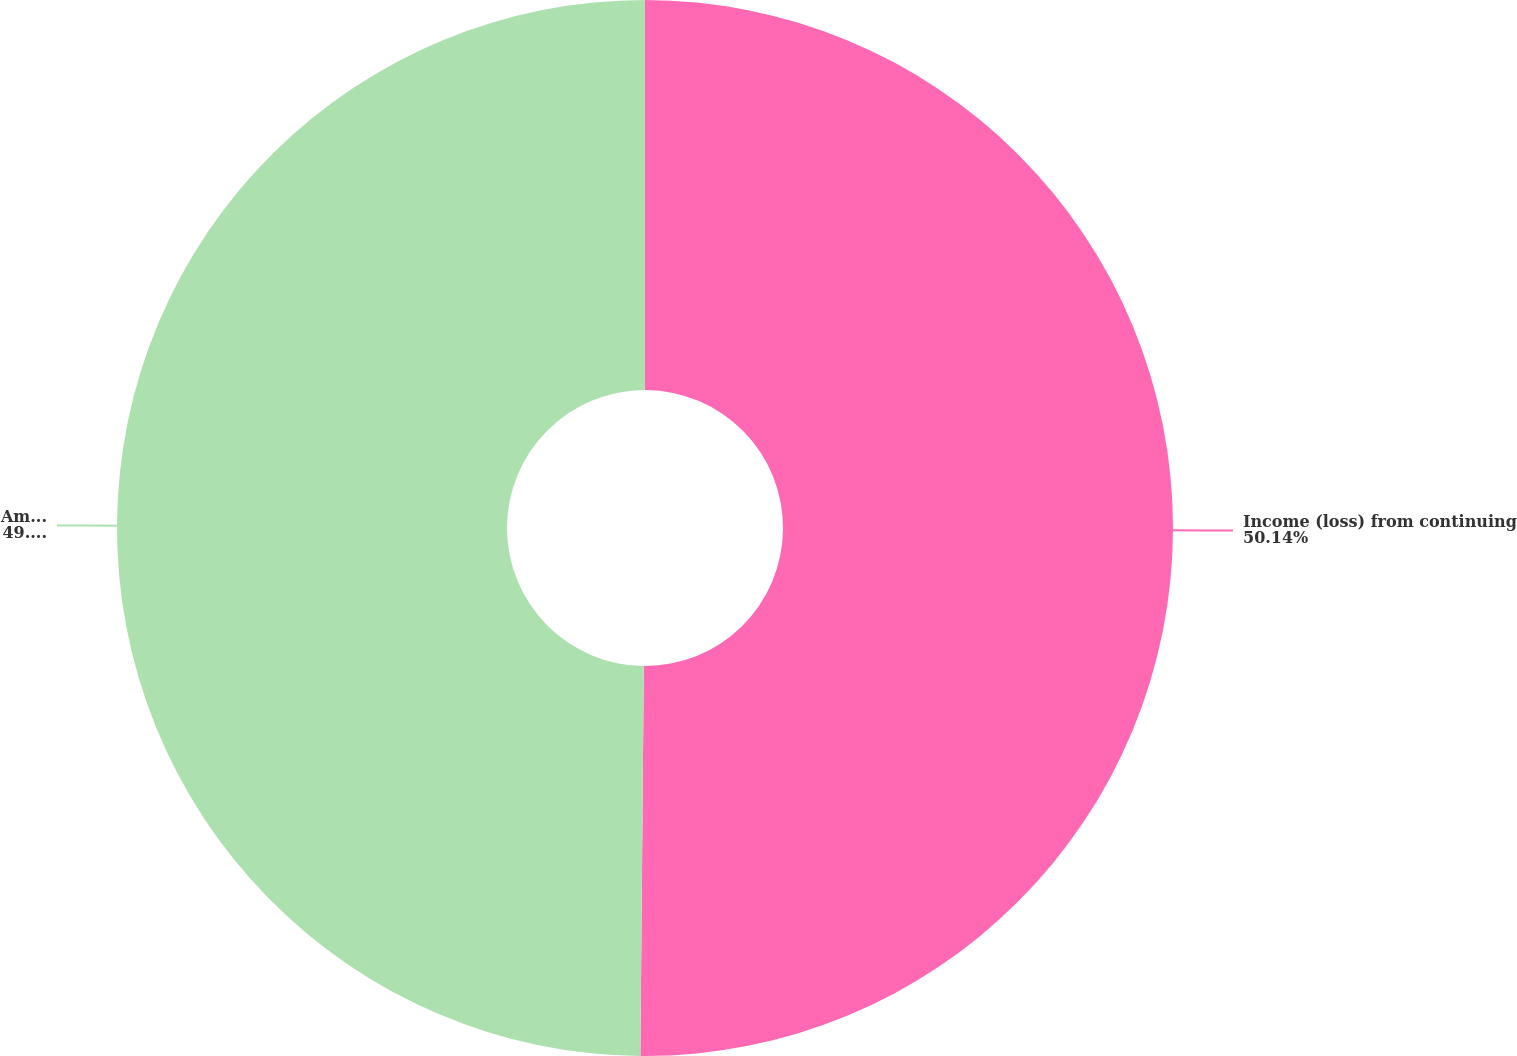<chart> <loc_0><loc_0><loc_500><loc_500><pie_chart><fcel>Income (loss) from continuing<fcel>Amounts attributable to common<nl><fcel>50.14%<fcel>49.86%<nl></chart> 